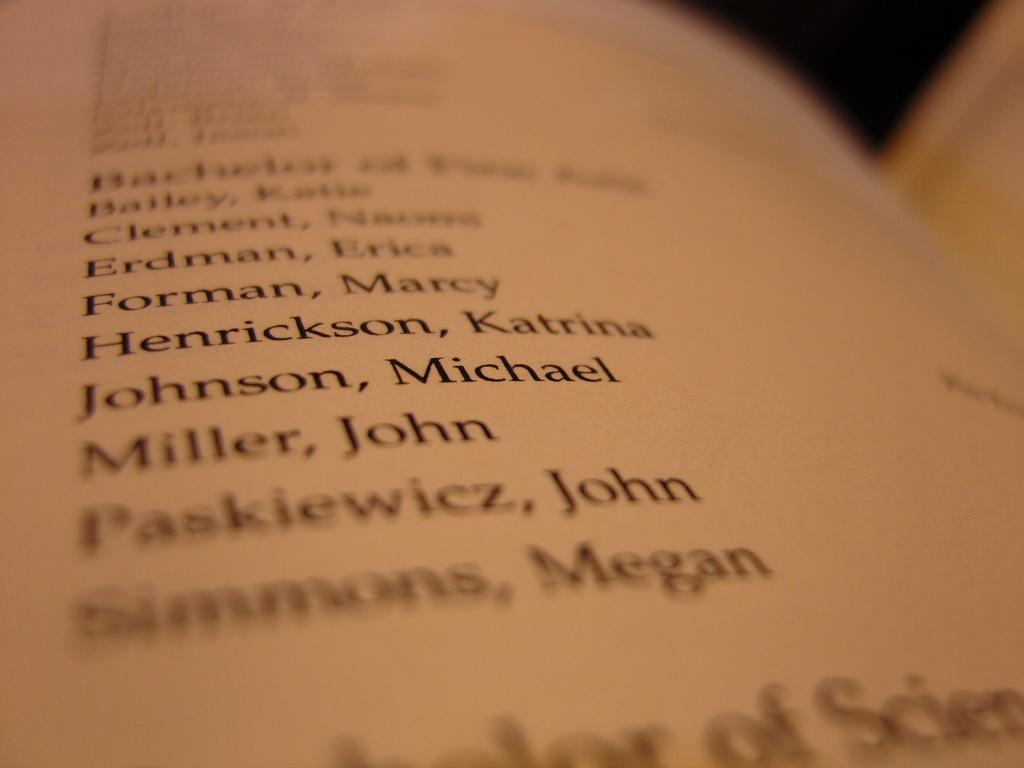<image>
Summarize the visual content of the image. An open textbook with a list of names on it. 